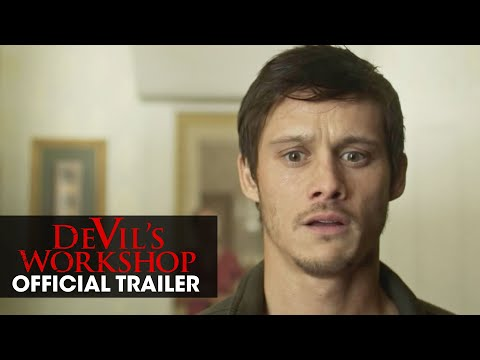Describe the mood and tone conveyed by the image. The mood of the image is tense and anticipatory, conveyed through the man's wide eyes and slightly open mouth, suggesting surprise or fear. The plain background with minimal decor and the bold red letters indicating the movie title and trailer enhance the sense of suspense and intrigue. What might the man be reacting to in the photo? The man's expression indicates that he might be reacting to something unexpected or alarming. Possible scenarios include witnessing a shocking event, encountering a supernatural entity, or suddenly realizing a critical piece of information. This reaction is intensified by the promotional context of the trailer, implying a dramatic or thrilling moment in the film. 